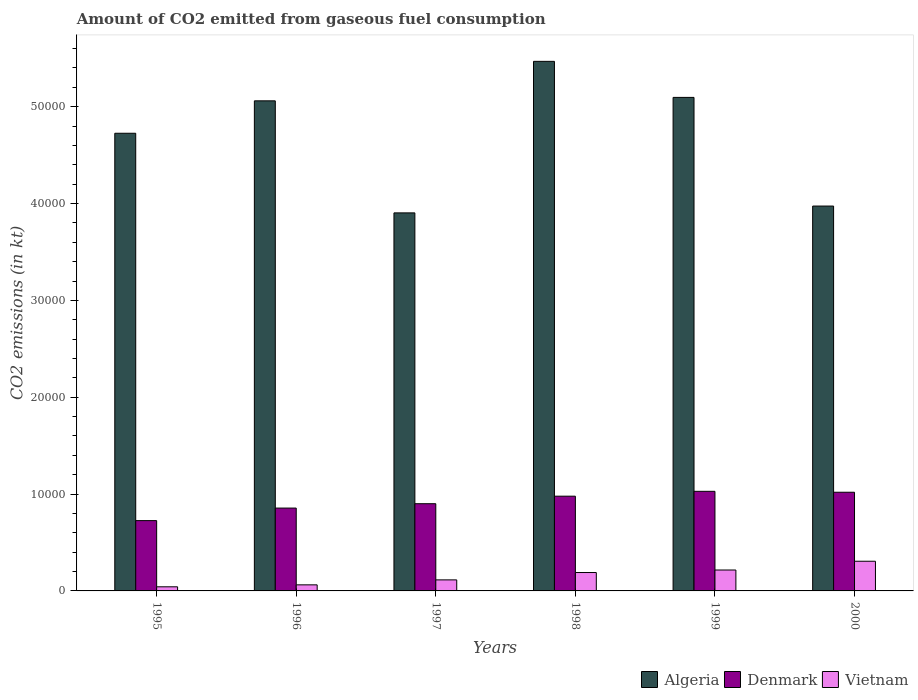How many different coloured bars are there?
Give a very brief answer. 3. How many bars are there on the 2nd tick from the left?
Make the answer very short. 3. How many bars are there on the 4th tick from the right?
Make the answer very short. 3. What is the amount of CO2 emitted in Vietnam in 1995?
Your response must be concise. 425.37. Across all years, what is the maximum amount of CO2 emitted in Denmark?
Make the answer very short. 1.03e+04. Across all years, what is the minimum amount of CO2 emitted in Vietnam?
Keep it short and to the point. 425.37. In which year was the amount of CO2 emitted in Denmark minimum?
Your response must be concise. 1995. What is the total amount of CO2 emitted in Denmark in the graph?
Provide a succinct answer. 5.51e+04. What is the difference between the amount of CO2 emitted in Algeria in 1995 and that in 1999?
Offer a very short reply. -3703.67. What is the difference between the amount of CO2 emitted in Algeria in 2000 and the amount of CO2 emitted in Vietnam in 1998?
Provide a succinct answer. 3.78e+04. What is the average amount of CO2 emitted in Algeria per year?
Offer a terse response. 4.71e+04. In the year 2000, what is the difference between the amount of CO2 emitted in Denmark and amount of CO2 emitted in Algeria?
Provide a short and direct response. -2.96e+04. In how many years, is the amount of CO2 emitted in Vietnam greater than 22000 kt?
Make the answer very short. 0. What is the ratio of the amount of CO2 emitted in Vietnam in 1995 to that in 1996?
Your answer should be compact. 0.68. What is the difference between the highest and the second highest amount of CO2 emitted in Vietnam?
Provide a succinct answer. 905.75. What is the difference between the highest and the lowest amount of CO2 emitted in Denmark?
Your response must be concise. 3025.27. What does the 2nd bar from the left in 1998 represents?
Your answer should be compact. Denmark. What does the 3rd bar from the right in 1998 represents?
Ensure brevity in your answer.  Algeria. Is it the case that in every year, the sum of the amount of CO2 emitted in Denmark and amount of CO2 emitted in Algeria is greater than the amount of CO2 emitted in Vietnam?
Make the answer very short. Yes. How many years are there in the graph?
Keep it short and to the point. 6. What is the difference between two consecutive major ticks on the Y-axis?
Ensure brevity in your answer.  10000. Are the values on the major ticks of Y-axis written in scientific E-notation?
Ensure brevity in your answer.  No. Does the graph contain any zero values?
Offer a terse response. No. Does the graph contain grids?
Provide a short and direct response. No. What is the title of the graph?
Make the answer very short. Amount of CO2 emitted from gaseous fuel consumption. What is the label or title of the X-axis?
Provide a succinct answer. Years. What is the label or title of the Y-axis?
Offer a very short reply. CO2 emissions (in kt). What is the CO2 emissions (in kt) in Algeria in 1995?
Your answer should be compact. 4.73e+04. What is the CO2 emissions (in kt) in Denmark in 1995?
Your answer should be compact. 7260.66. What is the CO2 emissions (in kt) in Vietnam in 1995?
Your answer should be very brief. 425.37. What is the CO2 emissions (in kt) in Algeria in 1996?
Ensure brevity in your answer.  5.06e+04. What is the CO2 emissions (in kt) of Denmark in 1996?
Your answer should be compact. 8555.11. What is the CO2 emissions (in kt) in Vietnam in 1996?
Offer a very short reply. 627.06. What is the CO2 emissions (in kt) in Algeria in 1997?
Provide a short and direct response. 3.90e+04. What is the CO2 emissions (in kt) of Denmark in 1997?
Ensure brevity in your answer.  9006.15. What is the CO2 emissions (in kt) of Vietnam in 1997?
Give a very brief answer. 1140.44. What is the CO2 emissions (in kt) in Algeria in 1998?
Provide a short and direct response. 5.47e+04. What is the CO2 emissions (in kt) of Denmark in 1998?
Your answer should be very brief. 9783.56. What is the CO2 emissions (in kt) in Vietnam in 1998?
Provide a succinct answer. 1899.51. What is the CO2 emissions (in kt) of Algeria in 1999?
Give a very brief answer. 5.10e+04. What is the CO2 emissions (in kt) of Denmark in 1999?
Offer a very short reply. 1.03e+04. What is the CO2 emissions (in kt) of Vietnam in 1999?
Ensure brevity in your answer.  2159.86. What is the CO2 emissions (in kt) of Algeria in 2000?
Your response must be concise. 3.97e+04. What is the CO2 emissions (in kt) of Denmark in 2000?
Keep it short and to the point. 1.02e+04. What is the CO2 emissions (in kt) in Vietnam in 2000?
Your response must be concise. 3065.61. Across all years, what is the maximum CO2 emissions (in kt) of Algeria?
Provide a succinct answer. 5.47e+04. Across all years, what is the maximum CO2 emissions (in kt) in Denmark?
Your answer should be very brief. 1.03e+04. Across all years, what is the maximum CO2 emissions (in kt) in Vietnam?
Your answer should be compact. 3065.61. Across all years, what is the minimum CO2 emissions (in kt) of Algeria?
Your answer should be compact. 3.90e+04. Across all years, what is the minimum CO2 emissions (in kt) in Denmark?
Keep it short and to the point. 7260.66. Across all years, what is the minimum CO2 emissions (in kt) of Vietnam?
Your answer should be very brief. 425.37. What is the total CO2 emissions (in kt) in Algeria in the graph?
Provide a succinct answer. 2.82e+05. What is the total CO2 emissions (in kt) of Denmark in the graph?
Provide a succinct answer. 5.51e+04. What is the total CO2 emissions (in kt) of Vietnam in the graph?
Provide a succinct answer. 9317.85. What is the difference between the CO2 emissions (in kt) in Algeria in 1995 and that in 1996?
Provide a succinct answer. -3347.97. What is the difference between the CO2 emissions (in kt) in Denmark in 1995 and that in 1996?
Make the answer very short. -1294.45. What is the difference between the CO2 emissions (in kt) of Vietnam in 1995 and that in 1996?
Give a very brief answer. -201.69. What is the difference between the CO2 emissions (in kt) of Algeria in 1995 and that in 1997?
Give a very brief answer. 8221.41. What is the difference between the CO2 emissions (in kt) in Denmark in 1995 and that in 1997?
Provide a succinct answer. -1745.49. What is the difference between the CO2 emissions (in kt) of Vietnam in 1995 and that in 1997?
Your answer should be compact. -715.07. What is the difference between the CO2 emissions (in kt) of Algeria in 1995 and that in 1998?
Keep it short and to the point. -7425.68. What is the difference between the CO2 emissions (in kt) in Denmark in 1995 and that in 1998?
Provide a succinct answer. -2522.9. What is the difference between the CO2 emissions (in kt) in Vietnam in 1995 and that in 1998?
Your response must be concise. -1474.13. What is the difference between the CO2 emissions (in kt) in Algeria in 1995 and that in 1999?
Offer a terse response. -3703.67. What is the difference between the CO2 emissions (in kt) in Denmark in 1995 and that in 1999?
Provide a succinct answer. -3025.28. What is the difference between the CO2 emissions (in kt) of Vietnam in 1995 and that in 1999?
Provide a succinct answer. -1734.49. What is the difference between the CO2 emissions (in kt) in Algeria in 1995 and that in 2000?
Offer a very short reply. 7517.35. What is the difference between the CO2 emissions (in kt) of Denmark in 1995 and that in 2000?
Offer a very short reply. -2929.93. What is the difference between the CO2 emissions (in kt) in Vietnam in 1995 and that in 2000?
Ensure brevity in your answer.  -2640.24. What is the difference between the CO2 emissions (in kt) of Algeria in 1996 and that in 1997?
Give a very brief answer. 1.16e+04. What is the difference between the CO2 emissions (in kt) in Denmark in 1996 and that in 1997?
Give a very brief answer. -451.04. What is the difference between the CO2 emissions (in kt) of Vietnam in 1996 and that in 1997?
Provide a succinct answer. -513.38. What is the difference between the CO2 emissions (in kt) in Algeria in 1996 and that in 1998?
Give a very brief answer. -4077.7. What is the difference between the CO2 emissions (in kt) of Denmark in 1996 and that in 1998?
Give a very brief answer. -1228.44. What is the difference between the CO2 emissions (in kt) of Vietnam in 1996 and that in 1998?
Give a very brief answer. -1272.45. What is the difference between the CO2 emissions (in kt) of Algeria in 1996 and that in 1999?
Give a very brief answer. -355.7. What is the difference between the CO2 emissions (in kt) in Denmark in 1996 and that in 1999?
Offer a terse response. -1730.82. What is the difference between the CO2 emissions (in kt) of Vietnam in 1996 and that in 1999?
Give a very brief answer. -1532.81. What is the difference between the CO2 emissions (in kt) in Algeria in 1996 and that in 2000?
Offer a very short reply. 1.09e+04. What is the difference between the CO2 emissions (in kt) in Denmark in 1996 and that in 2000?
Keep it short and to the point. -1635.48. What is the difference between the CO2 emissions (in kt) in Vietnam in 1996 and that in 2000?
Make the answer very short. -2438.55. What is the difference between the CO2 emissions (in kt) in Algeria in 1997 and that in 1998?
Your answer should be compact. -1.56e+04. What is the difference between the CO2 emissions (in kt) of Denmark in 1997 and that in 1998?
Give a very brief answer. -777.4. What is the difference between the CO2 emissions (in kt) in Vietnam in 1997 and that in 1998?
Your answer should be compact. -759.07. What is the difference between the CO2 emissions (in kt) in Algeria in 1997 and that in 1999?
Make the answer very short. -1.19e+04. What is the difference between the CO2 emissions (in kt) of Denmark in 1997 and that in 1999?
Your answer should be compact. -1279.78. What is the difference between the CO2 emissions (in kt) in Vietnam in 1997 and that in 1999?
Provide a succinct answer. -1019.43. What is the difference between the CO2 emissions (in kt) of Algeria in 1997 and that in 2000?
Make the answer very short. -704.06. What is the difference between the CO2 emissions (in kt) in Denmark in 1997 and that in 2000?
Give a very brief answer. -1184.44. What is the difference between the CO2 emissions (in kt) of Vietnam in 1997 and that in 2000?
Offer a very short reply. -1925.17. What is the difference between the CO2 emissions (in kt) in Algeria in 1998 and that in 1999?
Make the answer very short. 3722.01. What is the difference between the CO2 emissions (in kt) in Denmark in 1998 and that in 1999?
Ensure brevity in your answer.  -502.38. What is the difference between the CO2 emissions (in kt) in Vietnam in 1998 and that in 1999?
Give a very brief answer. -260.36. What is the difference between the CO2 emissions (in kt) of Algeria in 1998 and that in 2000?
Provide a succinct answer. 1.49e+04. What is the difference between the CO2 emissions (in kt) in Denmark in 1998 and that in 2000?
Offer a very short reply. -407.04. What is the difference between the CO2 emissions (in kt) of Vietnam in 1998 and that in 2000?
Your answer should be compact. -1166.11. What is the difference between the CO2 emissions (in kt) of Algeria in 1999 and that in 2000?
Keep it short and to the point. 1.12e+04. What is the difference between the CO2 emissions (in kt) of Denmark in 1999 and that in 2000?
Provide a succinct answer. 95.34. What is the difference between the CO2 emissions (in kt) in Vietnam in 1999 and that in 2000?
Keep it short and to the point. -905.75. What is the difference between the CO2 emissions (in kt) of Algeria in 1995 and the CO2 emissions (in kt) of Denmark in 1996?
Provide a short and direct response. 3.87e+04. What is the difference between the CO2 emissions (in kt) in Algeria in 1995 and the CO2 emissions (in kt) in Vietnam in 1996?
Keep it short and to the point. 4.66e+04. What is the difference between the CO2 emissions (in kt) in Denmark in 1995 and the CO2 emissions (in kt) in Vietnam in 1996?
Make the answer very short. 6633.6. What is the difference between the CO2 emissions (in kt) of Algeria in 1995 and the CO2 emissions (in kt) of Denmark in 1997?
Ensure brevity in your answer.  3.83e+04. What is the difference between the CO2 emissions (in kt) of Algeria in 1995 and the CO2 emissions (in kt) of Vietnam in 1997?
Your answer should be compact. 4.61e+04. What is the difference between the CO2 emissions (in kt) of Denmark in 1995 and the CO2 emissions (in kt) of Vietnam in 1997?
Give a very brief answer. 6120.22. What is the difference between the CO2 emissions (in kt) of Algeria in 1995 and the CO2 emissions (in kt) of Denmark in 1998?
Make the answer very short. 3.75e+04. What is the difference between the CO2 emissions (in kt) in Algeria in 1995 and the CO2 emissions (in kt) in Vietnam in 1998?
Your response must be concise. 4.54e+04. What is the difference between the CO2 emissions (in kt) in Denmark in 1995 and the CO2 emissions (in kt) in Vietnam in 1998?
Ensure brevity in your answer.  5361.15. What is the difference between the CO2 emissions (in kt) in Algeria in 1995 and the CO2 emissions (in kt) in Denmark in 1999?
Offer a very short reply. 3.70e+04. What is the difference between the CO2 emissions (in kt) of Algeria in 1995 and the CO2 emissions (in kt) of Vietnam in 1999?
Your answer should be compact. 4.51e+04. What is the difference between the CO2 emissions (in kt) in Denmark in 1995 and the CO2 emissions (in kt) in Vietnam in 1999?
Your answer should be very brief. 5100.8. What is the difference between the CO2 emissions (in kt) in Algeria in 1995 and the CO2 emissions (in kt) in Denmark in 2000?
Provide a succinct answer. 3.71e+04. What is the difference between the CO2 emissions (in kt) in Algeria in 1995 and the CO2 emissions (in kt) in Vietnam in 2000?
Provide a short and direct response. 4.42e+04. What is the difference between the CO2 emissions (in kt) of Denmark in 1995 and the CO2 emissions (in kt) of Vietnam in 2000?
Offer a very short reply. 4195.05. What is the difference between the CO2 emissions (in kt) in Algeria in 1996 and the CO2 emissions (in kt) in Denmark in 1997?
Make the answer very short. 4.16e+04. What is the difference between the CO2 emissions (in kt) of Algeria in 1996 and the CO2 emissions (in kt) of Vietnam in 1997?
Keep it short and to the point. 4.95e+04. What is the difference between the CO2 emissions (in kt) of Denmark in 1996 and the CO2 emissions (in kt) of Vietnam in 1997?
Keep it short and to the point. 7414.67. What is the difference between the CO2 emissions (in kt) of Algeria in 1996 and the CO2 emissions (in kt) of Denmark in 1998?
Your answer should be very brief. 4.08e+04. What is the difference between the CO2 emissions (in kt) of Algeria in 1996 and the CO2 emissions (in kt) of Vietnam in 1998?
Give a very brief answer. 4.87e+04. What is the difference between the CO2 emissions (in kt) in Denmark in 1996 and the CO2 emissions (in kt) in Vietnam in 1998?
Keep it short and to the point. 6655.6. What is the difference between the CO2 emissions (in kt) in Algeria in 1996 and the CO2 emissions (in kt) in Denmark in 1999?
Give a very brief answer. 4.03e+04. What is the difference between the CO2 emissions (in kt) in Algeria in 1996 and the CO2 emissions (in kt) in Vietnam in 1999?
Offer a terse response. 4.84e+04. What is the difference between the CO2 emissions (in kt) in Denmark in 1996 and the CO2 emissions (in kt) in Vietnam in 1999?
Offer a very short reply. 6395.25. What is the difference between the CO2 emissions (in kt) of Algeria in 1996 and the CO2 emissions (in kt) of Denmark in 2000?
Offer a very short reply. 4.04e+04. What is the difference between the CO2 emissions (in kt) in Algeria in 1996 and the CO2 emissions (in kt) in Vietnam in 2000?
Make the answer very short. 4.75e+04. What is the difference between the CO2 emissions (in kt) in Denmark in 1996 and the CO2 emissions (in kt) in Vietnam in 2000?
Give a very brief answer. 5489.5. What is the difference between the CO2 emissions (in kt) of Algeria in 1997 and the CO2 emissions (in kt) of Denmark in 1998?
Offer a terse response. 2.93e+04. What is the difference between the CO2 emissions (in kt) of Algeria in 1997 and the CO2 emissions (in kt) of Vietnam in 1998?
Your response must be concise. 3.71e+04. What is the difference between the CO2 emissions (in kt) in Denmark in 1997 and the CO2 emissions (in kt) in Vietnam in 1998?
Ensure brevity in your answer.  7106.65. What is the difference between the CO2 emissions (in kt) of Algeria in 1997 and the CO2 emissions (in kt) of Denmark in 1999?
Offer a terse response. 2.88e+04. What is the difference between the CO2 emissions (in kt) in Algeria in 1997 and the CO2 emissions (in kt) in Vietnam in 1999?
Make the answer very short. 3.69e+04. What is the difference between the CO2 emissions (in kt) in Denmark in 1997 and the CO2 emissions (in kt) in Vietnam in 1999?
Your answer should be very brief. 6846.29. What is the difference between the CO2 emissions (in kt) in Algeria in 1997 and the CO2 emissions (in kt) in Denmark in 2000?
Your response must be concise. 2.88e+04. What is the difference between the CO2 emissions (in kt) of Algeria in 1997 and the CO2 emissions (in kt) of Vietnam in 2000?
Your answer should be very brief. 3.60e+04. What is the difference between the CO2 emissions (in kt) in Denmark in 1997 and the CO2 emissions (in kt) in Vietnam in 2000?
Your answer should be very brief. 5940.54. What is the difference between the CO2 emissions (in kt) of Algeria in 1998 and the CO2 emissions (in kt) of Denmark in 1999?
Your answer should be compact. 4.44e+04. What is the difference between the CO2 emissions (in kt) in Algeria in 1998 and the CO2 emissions (in kt) in Vietnam in 1999?
Your answer should be compact. 5.25e+04. What is the difference between the CO2 emissions (in kt) in Denmark in 1998 and the CO2 emissions (in kt) in Vietnam in 1999?
Ensure brevity in your answer.  7623.69. What is the difference between the CO2 emissions (in kt) in Algeria in 1998 and the CO2 emissions (in kt) in Denmark in 2000?
Your answer should be very brief. 4.45e+04. What is the difference between the CO2 emissions (in kt) in Algeria in 1998 and the CO2 emissions (in kt) in Vietnam in 2000?
Your answer should be compact. 5.16e+04. What is the difference between the CO2 emissions (in kt) of Denmark in 1998 and the CO2 emissions (in kt) of Vietnam in 2000?
Your answer should be compact. 6717.94. What is the difference between the CO2 emissions (in kt) in Algeria in 1999 and the CO2 emissions (in kt) in Denmark in 2000?
Make the answer very short. 4.08e+04. What is the difference between the CO2 emissions (in kt) of Algeria in 1999 and the CO2 emissions (in kt) of Vietnam in 2000?
Give a very brief answer. 4.79e+04. What is the difference between the CO2 emissions (in kt) in Denmark in 1999 and the CO2 emissions (in kt) in Vietnam in 2000?
Your answer should be compact. 7220.32. What is the average CO2 emissions (in kt) in Algeria per year?
Ensure brevity in your answer.  4.71e+04. What is the average CO2 emissions (in kt) of Denmark per year?
Give a very brief answer. 9180.33. What is the average CO2 emissions (in kt) in Vietnam per year?
Your answer should be very brief. 1552.97. In the year 1995, what is the difference between the CO2 emissions (in kt) of Algeria and CO2 emissions (in kt) of Denmark?
Offer a terse response. 4.00e+04. In the year 1995, what is the difference between the CO2 emissions (in kt) in Algeria and CO2 emissions (in kt) in Vietnam?
Your answer should be very brief. 4.68e+04. In the year 1995, what is the difference between the CO2 emissions (in kt) in Denmark and CO2 emissions (in kt) in Vietnam?
Make the answer very short. 6835.29. In the year 1996, what is the difference between the CO2 emissions (in kt) of Algeria and CO2 emissions (in kt) of Denmark?
Offer a terse response. 4.21e+04. In the year 1996, what is the difference between the CO2 emissions (in kt) of Algeria and CO2 emissions (in kt) of Vietnam?
Your answer should be very brief. 5.00e+04. In the year 1996, what is the difference between the CO2 emissions (in kt) in Denmark and CO2 emissions (in kt) in Vietnam?
Offer a terse response. 7928.05. In the year 1997, what is the difference between the CO2 emissions (in kt) of Algeria and CO2 emissions (in kt) of Denmark?
Provide a short and direct response. 3.00e+04. In the year 1997, what is the difference between the CO2 emissions (in kt) of Algeria and CO2 emissions (in kt) of Vietnam?
Your answer should be very brief. 3.79e+04. In the year 1997, what is the difference between the CO2 emissions (in kt) in Denmark and CO2 emissions (in kt) in Vietnam?
Offer a terse response. 7865.72. In the year 1998, what is the difference between the CO2 emissions (in kt) of Algeria and CO2 emissions (in kt) of Denmark?
Offer a terse response. 4.49e+04. In the year 1998, what is the difference between the CO2 emissions (in kt) in Algeria and CO2 emissions (in kt) in Vietnam?
Your response must be concise. 5.28e+04. In the year 1998, what is the difference between the CO2 emissions (in kt) of Denmark and CO2 emissions (in kt) of Vietnam?
Offer a terse response. 7884.05. In the year 1999, what is the difference between the CO2 emissions (in kt) in Algeria and CO2 emissions (in kt) in Denmark?
Provide a short and direct response. 4.07e+04. In the year 1999, what is the difference between the CO2 emissions (in kt) of Algeria and CO2 emissions (in kt) of Vietnam?
Keep it short and to the point. 4.88e+04. In the year 1999, what is the difference between the CO2 emissions (in kt) in Denmark and CO2 emissions (in kt) in Vietnam?
Your response must be concise. 8126.07. In the year 2000, what is the difference between the CO2 emissions (in kt) in Algeria and CO2 emissions (in kt) in Denmark?
Give a very brief answer. 2.96e+04. In the year 2000, what is the difference between the CO2 emissions (in kt) in Algeria and CO2 emissions (in kt) in Vietnam?
Your answer should be very brief. 3.67e+04. In the year 2000, what is the difference between the CO2 emissions (in kt) of Denmark and CO2 emissions (in kt) of Vietnam?
Keep it short and to the point. 7124.98. What is the ratio of the CO2 emissions (in kt) in Algeria in 1995 to that in 1996?
Your answer should be compact. 0.93. What is the ratio of the CO2 emissions (in kt) of Denmark in 1995 to that in 1996?
Make the answer very short. 0.85. What is the ratio of the CO2 emissions (in kt) in Vietnam in 1995 to that in 1996?
Your answer should be very brief. 0.68. What is the ratio of the CO2 emissions (in kt) of Algeria in 1995 to that in 1997?
Keep it short and to the point. 1.21. What is the ratio of the CO2 emissions (in kt) in Denmark in 1995 to that in 1997?
Offer a terse response. 0.81. What is the ratio of the CO2 emissions (in kt) of Vietnam in 1995 to that in 1997?
Offer a terse response. 0.37. What is the ratio of the CO2 emissions (in kt) in Algeria in 1995 to that in 1998?
Make the answer very short. 0.86. What is the ratio of the CO2 emissions (in kt) of Denmark in 1995 to that in 1998?
Your answer should be compact. 0.74. What is the ratio of the CO2 emissions (in kt) of Vietnam in 1995 to that in 1998?
Ensure brevity in your answer.  0.22. What is the ratio of the CO2 emissions (in kt) of Algeria in 1995 to that in 1999?
Ensure brevity in your answer.  0.93. What is the ratio of the CO2 emissions (in kt) of Denmark in 1995 to that in 1999?
Provide a short and direct response. 0.71. What is the ratio of the CO2 emissions (in kt) of Vietnam in 1995 to that in 1999?
Your answer should be very brief. 0.2. What is the ratio of the CO2 emissions (in kt) in Algeria in 1995 to that in 2000?
Provide a succinct answer. 1.19. What is the ratio of the CO2 emissions (in kt) in Denmark in 1995 to that in 2000?
Provide a succinct answer. 0.71. What is the ratio of the CO2 emissions (in kt) of Vietnam in 1995 to that in 2000?
Your answer should be very brief. 0.14. What is the ratio of the CO2 emissions (in kt) in Algeria in 1996 to that in 1997?
Offer a very short reply. 1.3. What is the ratio of the CO2 emissions (in kt) of Denmark in 1996 to that in 1997?
Give a very brief answer. 0.95. What is the ratio of the CO2 emissions (in kt) in Vietnam in 1996 to that in 1997?
Provide a short and direct response. 0.55. What is the ratio of the CO2 emissions (in kt) in Algeria in 1996 to that in 1998?
Offer a very short reply. 0.93. What is the ratio of the CO2 emissions (in kt) of Denmark in 1996 to that in 1998?
Make the answer very short. 0.87. What is the ratio of the CO2 emissions (in kt) of Vietnam in 1996 to that in 1998?
Your answer should be very brief. 0.33. What is the ratio of the CO2 emissions (in kt) in Algeria in 1996 to that in 1999?
Offer a terse response. 0.99. What is the ratio of the CO2 emissions (in kt) in Denmark in 1996 to that in 1999?
Provide a succinct answer. 0.83. What is the ratio of the CO2 emissions (in kt) in Vietnam in 1996 to that in 1999?
Your answer should be compact. 0.29. What is the ratio of the CO2 emissions (in kt) of Algeria in 1996 to that in 2000?
Your answer should be very brief. 1.27. What is the ratio of the CO2 emissions (in kt) in Denmark in 1996 to that in 2000?
Provide a succinct answer. 0.84. What is the ratio of the CO2 emissions (in kt) of Vietnam in 1996 to that in 2000?
Your response must be concise. 0.2. What is the ratio of the CO2 emissions (in kt) of Algeria in 1997 to that in 1998?
Your response must be concise. 0.71. What is the ratio of the CO2 emissions (in kt) of Denmark in 1997 to that in 1998?
Offer a terse response. 0.92. What is the ratio of the CO2 emissions (in kt) of Vietnam in 1997 to that in 1998?
Make the answer very short. 0.6. What is the ratio of the CO2 emissions (in kt) in Algeria in 1997 to that in 1999?
Your response must be concise. 0.77. What is the ratio of the CO2 emissions (in kt) in Denmark in 1997 to that in 1999?
Give a very brief answer. 0.88. What is the ratio of the CO2 emissions (in kt) of Vietnam in 1997 to that in 1999?
Your answer should be compact. 0.53. What is the ratio of the CO2 emissions (in kt) in Algeria in 1997 to that in 2000?
Your answer should be compact. 0.98. What is the ratio of the CO2 emissions (in kt) of Denmark in 1997 to that in 2000?
Ensure brevity in your answer.  0.88. What is the ratio of the CO2 emissions (in kt) of Vietnam in 1997 to that in 2000?
Provide a succinct answer. 0.37. What is the ratio of the CO2 emissions (in kt) of Algeria in 1998 to that in 1999?
Give a very brief answer. 1.07. What is the ratio of the CO2 emissions (in kt) of Denmark in 1998 to that in 1999?
Ensure brevity in your answer.  0.95. What is the ratio of the CO2 emissions (in kt) of Vietnam in 1998 to that in 1999?
Offer a very short reply. 0.88. What is the ratio of the CO2 emissions (in kt) of Algeria in 1998 to that in 2000?
Offer a terse response. 1.38. What is the ratio of the CO2 emissions (in kt) of Denmark in 1998 to that in 2000?
Ensure brevity in your answer.  0.96. What is the ratio of the CO2 emissions (in kt) of Vietnam in 1998 to that in 2000?
Make the answer very short. 0.62. What is the ratio of the CO2 emissions (in kt) of Algeria in 1999 to that in 2000?
Give a very brief answer. 1.28. What is the ratio of the CO2 emissions (in kt) of Denmark in 1999 to that in 2000?
Your answer should be compact. 1.01. What is the ratio of the CO2 emissions (in kt) of Vietnam in 1999 to that in 2000?
Your response must be concise. 0.7. What is the difference between the highest and the second highest CO2 emissions (in kt) in Algeria?
Offer a terse response. 3722.01. What is the difference between the highest and the second highest CO2 emissions (in kt) of Denmark?
Provide a succinct answer. 95.34. What is the difference between the highest and the second highest CO2 emissions (in kt) in Vietnam?
Make the answer very short. 905.75. What is the difference between the highest and the lowest CO2 emissions (in kt) in Algeria?
Ensure brevity in your answer.  1.56e+04. What is the difference between the highest and the lowest CO2 emissions (in kt) of Denmark?
Keep it short and to the point. 3025.28. What is the difference between the highest and the lowest CO2 emissions (in kt) in Vietnam?
Provide a succinct answer. 2640.24. 